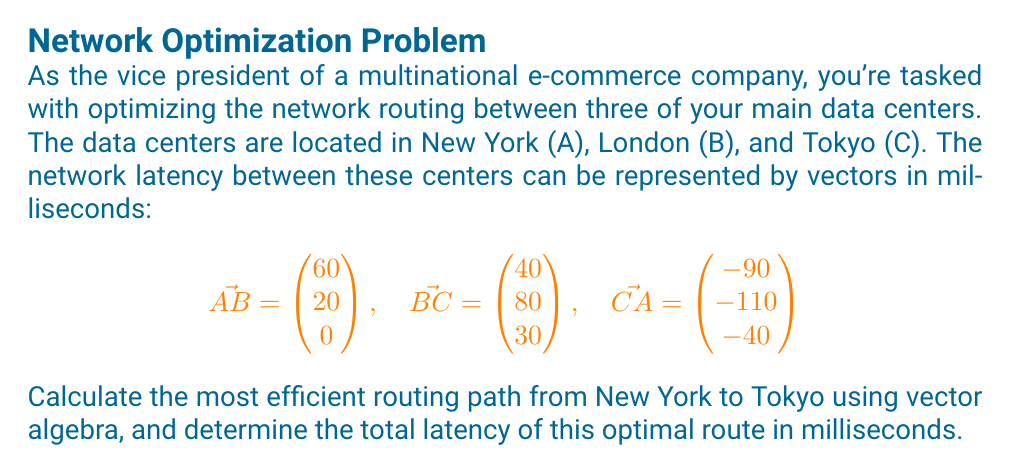Solve this math problem. To solve this problem, we'll follow these steps:

1) First, we need to determine all possible paths from New York (A) to Tokyo (C):
   - Direct path: A to C
   - Indirect path: A to B to C

2) For the direct path (A to C):
   We can use the vector $\vec{CA}$ but in the opposite direction:
   $$\vec{AC} = -\vec{CA} = \begin{pmatrix} 90 \\ 110 \\ 40 \end{pmatrix}$$
   The magnitude of this vector represents the latency:
   $$|\vec{AC}| = \sqrt{90^2 + 110^2 + 40^2} = \sqrt{22500} = 150\text{ ms}$$

3) For the indirect path (A to B to C):
   We add the vectors $\vec{AB}$ and $\vec{BC}$:
   $$\vec{AB} + \vec{BC} = \begin{pmatrix} 60 \\ 20 \\ 0 \end{pmatrix} + \begin{pmatrix} 40 \\ 80 \\ 30 \end{pmatrix} = \begin{pmatrix} 100 \\ 100 \\ 30 \end{pmatrix}$$
   The magnitude of this resultant vector is:
   $$|\vec{AB} + \vec{BC}| = \sqrt{100^2 + 100^2 + 30^2} = \sqrt{20900} \approx 144.57\text{ ms}$$

4) Comparing the two paths:
   - Direct path (A to C): 150 ms
   - Indirect path (A to B to C): 144.57 ms

Therefore, the most efficient routing path from New York to Tokyo is the indirect path through London, with a total latency of approximately 144.57 ms.
Answer: A → B → C; 144.57 ms 